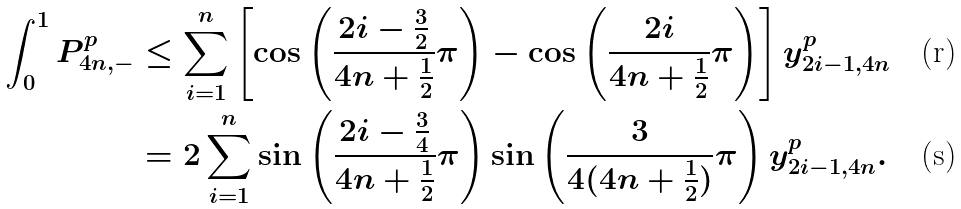Convert formula to latex. <formula><loc_0><loc_0><loc_500><loc_500>\int _ { 0 } ^ { 1 } P _ { 4 n , - } ^ { p } & \leq \sum _ { i = 1 } ^ { n } \left [ \cos \left ( \frac { 2 i - \frac { 3 } { 2 } } { 4 n + \frac { 1 } { 2 } } \pi \right ) - \cos \left ( \frac { 2 i } { 4 n + \frac { 1 } { 2 } } \pi \right ) \right ] y _ { 2 i - 1 , 4 n } ^ { p } \\ & = 2 \sum _ { i = 1 } ^ { n } \sin \left ( \frac { 2 i - \frac { 3 } { 4 } } { 4 n + \frac { 1 } { 2 } } \pi \right ) \sin \left ( \frac { 3 } { 4 ( 4 n + \frac { 1 } { 2 } ) } \pi \right ) y _ { 2 i - 1 , 4 n } ^ { p } .</formula> 